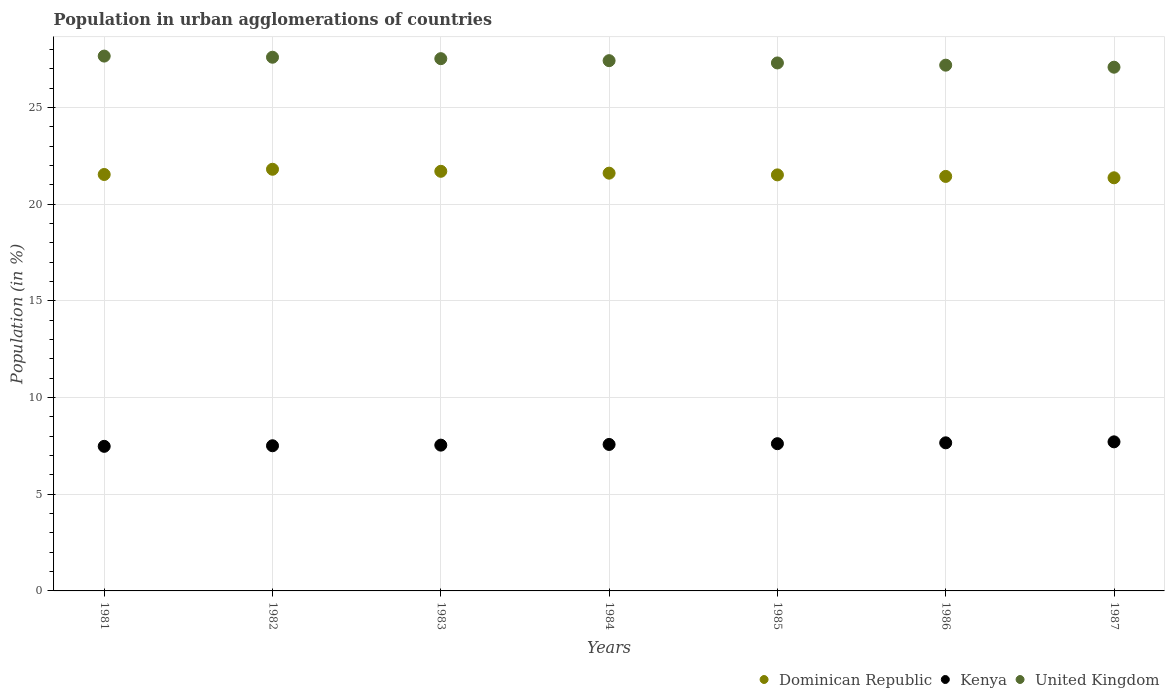Is the number of dotlines equal to the number of legend labels?
Your response must be concise. Yes. What is the percentage of population in urban agglomerations in Kenya in 1982?
Give a very brief answer. 7.51. Across all years, what is the maximum percentage of population in urban agglomerations in Kenya?
Your answer should be very brief. 7.71. Across all years, what is the minimum percentage of population in urban agglomerations in Kenya?
Make the answer very short. 7.48. In which year was the percentage of population in urban agglomerations in Kenya maximum?
Your answer should be very brief. 1987. What is the total percentage of population in urban agglomerations in Kenya in the graph?
Your answer should be very brief. 53.09. What is the difference between the percentage of population in urban agglomerations in Kenya in 1986 and that in 1987?
Offer a very short reply. -0.05. What is the difference between the percentage of population in urban agglomerations in Kenya in 1983 and the percentage of population in urban agglomerations in United Kingdom in 1982?
Offer a terse response. -20.06. What is the average percentage of population in urban agglomerations in Kenya per year?
Make the answer very short. 7.58. In the year 1982, what is the difference between the percentage of population in urban agglomerations in United Kingdom and percentage of population in urban agglomerations in Dominican Republic?
Give a very brief answer. 5.79. What is the ratio of the percentage of population in urban agglomerations in United Kingdom in 1984 to that in 1987?
Keep it short and to the point. 1.01. Is the percentage of population in urban agglomerations in United Kingdom in 1984 less than that in 1986?
Ensure brevity in your answer.  No. What is the difference between the highest and the second highest percentage of population in urban agglomerations in Dominican Republic?
Ensure brevity in your answer.  0.11. What is the difference between the highest and the lowest percentage of population in urban agglomerations in Dominican Republic?
Provide a short and direct response. 0.44. Does the percentage of population in urban agglomerations in Dominican Republic monotonically increase over the years?
Offer a very short reply. No. Is the percentage of population in urban agglomerations in United Kingdom strictly greater than the percentage of population in urban agglomerations in Dominican Republic over the years?
Keep it short and to the point. Yes. Is the percentage of population in urban agglomerations in Dominican Republic strictly less than the percentage of population in urban agglomerations in Kenya over the years?
Ensure brevity in your answer.  No. How many years are there in the graph?
Ensure brevity in your answer.  7. Does the graph contain any zero values?
Keep it short and to the point. No. Where does the legend appear in the graph?
Give a very brief answer. Bottom right. What is the title of the graph?
Give a very brief answer. Population in urban agglomerations of countries. Does "Curacao" appear as one of the legend labels in the graph?
Offer a very short reply. No. What is the label or title of the Y-axis?
Give a very brief answer. Population (in %). What is the Population (in %) in Dominican Republic in 1981?
Provide a succinct answer. 21.54. What is the Population (in %) of Kenya in 1981?
Your response must be concise. 7.48. What is the Population (in %) of United Kingdom in 1981?
Keep it short and to the point. 27.66. What is the Population (in %) of Dominican Republic in 1982?
Provide a succinct answer. 21.81. What is the Population (in %) in Kenya in 1982?
Your response must be concise. 7.51. What is the Population (in %) of United Kingdom in 1982?
Ensure brevity in your answer.  27.6. What is the Population (in %) in Dominican Republic in 1983?
Your response must be concise. 21.7. What is the Population (in %) of Kenya in 1983?
Offer a terse response. 7.54. What is the Population (in %) of United Kingdom in 1983?
Make the answer very short. 27.53. What is the Population (in %) of Dominican Republic in 1984?
Make the answer very short. 21.61. What is the Population (in %) in Kenya in 1984?
Your answer should be compact. 7.58. What is the Population (in %) in United Kingdom in 1984?
Your response must be concise. 27.43. What is the Population (in %) of Dominican Republic in 1985?
Your answer should be very brief. 21.52. What is the Population (in %) in Kenya in 1985?
Provide a short and direct response. 7.62. What is the Population (in %) of United Kingdom in 1985?
Give a very brief answer. 27.31. What is the Population (in %) of Dominican Republic in 1986?
Provide a short and direct response. 21.44. What is the Population (in %) of Kenya in 1986?
Your response must be concise. 7.66. What is the Population (in %) in United Kingdom in 1986?
Your answer should be compact. 27.19. What is the Population (in %) of Dominican Republic in 1987?
Offer a terse response. 21.37. What is the Population (in %) of Kenya in 1987?
Make the answer very short. 7.71. What is the Population (in %) of United Kingdom in 1987?
Make the answer very short. 27.09. Across all years, what is the maximum Population (in %) of Dominican Republic?
Offer a terse response. 21.81. Across all years, what is the maximum Population (in %) of Kenya?
Your answer should be compact. 7.71. Across all years, what is the maximum Population (in %) of United Kingdom?
Your answer should be very brief. 27.66. Across all years, what is the minimum Population (in %) in Dominican Republic?
Offer a terse response. 21.37. Across all years, what is the minimum Population (in %) in Kenya?
Offer a terse response. 7.48. Across all years, what is the minimum Population (in %) in United Kingdom?
Give a very brief answer. 27.09. What is the total Population (in %) of Dominican Republic in the graph?
Your answer should be compact. 150.99. What is the total Population (in %) of Kenya in the graph?
Give a very brief answer. 53.09. What is the total Population (in %) in United Kingdom in the graph?
Your answer should be very brief. 191.81. What is the difference between the Population (in %) in Dominican Republic in 1981 and that in 1982?
Offer a terse response. -0.27. What is the difference between the Population (in %) in Kenya in 1981 and that in 1982?
Keep it short and to the point. -0.03. What is the difference between the Population (in %) in United Kingdom in 1981 and that in 1982?
Make the answer very short. 0.06. What is the difference between the Population (in %) in Dominican Republic in 1981 and that in 1983?
Make the answer very short. -0.16. What is the difference between the Population (in %) of Kenya in 1981 and that in 1983?
Your response must be concise. -0.06. What is the difference between the Population (in %) of United Kingdom in 1981 and that in 1983?
Provide a succinct answer. 0.13. What is the difference between the Population (in %) of Dominican Republic in 1981 and that in 1984?
Your answer should be compact. -0.07. What is the difference between the Population (in %) in Kenya in 1981 and that in 1984?
Make the answer very short. -0.1. What is the difference between the Population (in %) in United Kingdom in 1981 and that in 1984?
Ensure brevity in your answer.  0.24. What is the difference between the Population (in %) of Dominican Republic in 1981 and that in 1985?
Give a very brief answer. 0.02. What is the difference between the Population (in %) in Kenya in 1981 and that in 1985?
Ensure brevity in your answer.  -0.14. What is the difference between the Population (in %) of United Kingdom in 1981 and that in 1985?
Your answer should be compact. 0.35. What is the difference between the Population (in %) of Dominican Republic in 1981 and that in 1986?
Your response must be concise. 0.1. What is the difference between the Population (in %) of Kenya in 1981 and that in 1986?
Offer a terse response. -0.18. What is the difference between the Population (in %) in United Kingdom in 1981 and that in 1986?
Offer a very short reply. 0.47. What is the difference between the Population (in %) of Dominican Republic in 1981 and that in 1987?
Provide a succinct answer. 0.17. What is the difference between the Population (in %) of Kenya in 1981 and that in 1987?
Make the answer very short. -0.23. What is the difference between the Population (in %) of United Kingdom in 1981 and that in 1987?
Keep it short and to the point. 0.57. What is the difference between the Population (in %) in Dominican Republic in 1982 and that in 1983?
Your answer should be very brief. 0.11. What is the difference between the Population (in %) in Kenya in 1982 and that in 1983?
Keep it short and to the point. -0.03. What is the difference between the Population (in %) in United Kingdom in 1982 and that in 1983?
Make the answer very short. 0.07. What is the difference between the Population (in %) in Dominican Republic in 1982 and that in 1984?
Your answer should be compact. 0.2. What is the difference between the Population (in %) in Kenya in 1982 and that in 1984?
Your answer should be very brief. -0.07. What is the difference between the Population (in %) of United Kingdom in 1982 and that in 1984?
Your response must be concise. 0.18. What is the difference between the Population (in %) in Dominican Republic in 1982 and that in 1985?
Your answer should be compact. 0.29. What is the difference between the Population (in %) of Kenya in 1982 and that in 1985?
Ensure brevity in your answer.  -0.11. What is the difference between the Population (in %) of United Kingdom in 1982 and that in 1985?
Offer a terse response. 0.3. What is the difference between the Population (in %) of Dominican Republic in 1982 and that in 1986?
Provide a short and direct response. 0.37. What is the difference between the Population (in %) of Kenya in 1982 and that in 1986?
Your answer should be compact. -0.15. What is the difference between the Population (in %) of United Kingdom in 1982 and that in 1986?
Your answer should be very brief. 0.41. What is the difference between the Population (in %) in Dominican Republic in 1982 and that in 1987?
Give a very brief answer. 0.44. What is the difference between the Population (in %) of Kenya in 1982 and that in 1987?
Provide a succinct answer. -0.2. What is the difference between the Population (in %) of United Kingdom in 1982 and that in 1987?
Your response must be concise. 0.52. What is the difference between the Population (in %) of Dominican Republic in 1983 and that in 1984?
Ensure brevity in your answer.  0.1. What is the difference between the Population (in %) in Kenya in 1983 and that in 1984?
Your answer should be very brief. -0.04. What is the difference between the Population (in %) in United Kingdom in 1983 and that in 1984?
Provide a succinct answer. 0.1. What is the difference between the Population (in %) in Dominican Republic in 1983 and that in 1985?
Ensure brevity in your answer.  0.18. What is the difference between the Population (in %) of Kenya in 1983 and that in 1985?
Provide a succinct answer. -0.07. What is the difference between the Population (in %) of United Kingdom in 1983 and that in 1985?
Your answer should be very brief. 0.22. What is the difference between the Population (in %) in Dominican Republic in 1983 and that in 1986?
Your answer should be compact. 0.26. What is the difference between the Population (in %) of Kenya in 1983 and that in 1986?
Give a very brief answer. -0.12. What is the difference between the Population (in %) in United Kingdom in 1983 and that in 1986?
Your answer should be compact. 0.34. What is the difference between the Population (in %) in Dominican Republic in 1983 and that in 1987?
Make the answer very short. 0.34. What is the difference between the Population (in %) of Kenya in 1983 and that in 1987?
Give a very brief answer. -0.17. What is the difference between the Population (in %) in United Kingdom in 1983 and that in 1987?
Provide a succinct answer. 0.44. What is the difference between the Population (in %) in Dominican Republic in 1984 and that in 1985?
Ensure brevity in your answer.  0.09. What is the difference between the Population (in %) of Kenya in 1984 and that in 1985?
Make the answer very short. -0.04. What is the difference between the Population (in %) of United Kingdom in 1984 and that in 1985?
Offer a very short reply. 0.12. What is the difference between the Population (in %) in Dominican Republic in 1984 and that in 1986?
Provide a short and direct response. 0.17. What is the difference between the Population (in %) of Kenya in 1984 and that in 1986?
Your response must be concise. -0.08. What is the difference between the Population (in %) of United Kingdom in 1984 and that in 1986?
Offer a very short reply. 0.23. What is the difference between the Population (in %) in Dominican Republic in 1984 and that in 1987?
Your answer should be very brief. 0.24. What is the difference between the Population (in %) in Kenya in 1984 and that in 1987?
Your answer should be compact. -0.13. What is the difference between the Population (in %) in United Kingdom in 1984 and that in 1987?
Offer a terse response. 0.34. What is the difference between the Population (in %) of Dominican Republic in 1985 and that in 1986?
Provide a succinct answer. 0.08. What is the difference between the Population (in %) of Kenya in 1985 and that in 1986?
Your answer should be compact. -0.04. What is the difference between the Population (in %) in United Kingdom in 1985 and that in 1986?
Your response must be concise. 0.11. What is the difference between the Population (in %) in Dominican Republic in 1985 and that in 1987?
Your answer should be very brief. 0.15. What is the difference between the Population (in %) in Kenya in 1985 and that in 1987?
Keep it short and to the point. -0.1. What is the difference between the Population (in %) of United Kingdom in 1985 and that in 1987?
Give a very brief answer. 0.22. What is the difference between the Population (in %) in Dominican Republic in 1986 and that in 1987?
Your response must be concise. 0.07. What is the difference between the Population (in %) of Kenya in 1986 and that in 1987?
Your response must be concise. -0.05. What is the difference between the Population (in %) in United Kingdom in 1986 and that in 1987?
Give a very brief answer. 0.11. What is the difference between the Population (in %) in Dominican Republic in 1981 and the Population (in %) in Kenya in 1982?
Make the answer very short. 14.03. What is the difference between the Population (in %) in Dominican Republic in 1981 and the Population (in %) in United Kingdom in 1982?
Make the answer very short. -6.06. What is the difference between the Population (in %) in Kenya in 1981 and the Population (in %) in United Kingdom in 1982?
Your response must be concise. -20.13. What is the difference between the Population (in %) of Dominican Republic in 1981 and the Population (in %) of Kenya in 1983?
Provide a succinct answer. 14. What is the difference between the Population (in %) in Dominican Republic in 1981 and the Population (in %) in United Kingdom in 1983?
Your response must be concise. -5.99. What is the difference between the Population (in %) in Kenya in 1981 and the Population (in %) in United Kingdom in 1983?
Your response must be concise. -20.05. What is the difference between the Population (in %) in Dominican Republic in 1981 and the Population (in %) in Kenya in 1984?
Offer a terse response. 13.96. What is the difference between the Population (in %) of Dominican Republic in 1981 and the Population (in %) of United Kingdom in 1984?
Your answer should be very brief. -5.89. What is the difference between the Population (in %) in Kenya in 1981 and the Population (in %) in United Kingdom in 1984?
Your response must be concise. -19.95. What is the difference between the Population (in %) of Dominican Republic in 1981 and the Population (in %) of Kenya in 1985?
Provide a short and direct response. 13.92. What is the difference between the Population (in %) of Dominican Republic in 1981 and the Population (in %) of United Kingdom in 1985?
Offer a very short reply. -5.77. What is the difference between the Population (in %) in Kenya in 1981 and the Population (in %) in United Kingdom in 1985?
Provide a succinct answer. -19.83. What is the difference between the Population (in %) in Dominican Republic in 1981 and the Population (in %) in Kenya in 1986?
Keep it short and to the point. 13.88. What is the difference between the Population (in %) of Dominican Republic in 1981 and the Population (in %) of United Kingdom in 1986?
Ensure brevity in your answer.  -5.65. What is the difference between the Population (in %) in Kenya in 1981 and the Population (in %) in United Kingdom in 1986?
Give a very brief answer. -19.72. What is the difference between the Population (in %) of Dominican Republic in 1981 and the Population (in %) of Kenya in 1987?
Keep it short and to the point. 13.83. What is the difference between the Population (in %) in Dominican Republic in 1981 and the Population (in %) in United Kingdom in 1987?
Your answer should be compact. -5.55. What is the difference between the Population (in %) of Kenya in 1981 and the Population (in %) of United Kingdom in 1987?
Offer a terse response. -19.61. What is the difference between the Population (in %) of Dominican Republic in 1982 and the Population (in %) of Kenya in 1983?
Keep it short and to the point. 14.27. What is the difference between the Population (in %) of Dominican Republic in 1982 and the Population (in %) of United Kingdom in 1983?
Make the answer very short. -5.72. What is the difference between the Population (in %) of Kenya in 1982 and the Population (in %) of United Kingdom in 1983?
Offer a terse response. -20.02. What is the difference between the Population (in %) in Dominican Republic in 1982 and the Population (in %) in Kenya in 1984?
Ensure brevity in your answer.  14.23. What is the difference between the Population (in %) of Dominican Republic in 1982 and the Population (in %) of United Kingdom in 1984?
Offer a terse response. -5.62. What is the difference between the Population (in %) in Kenya in 1982 and the Population (in %) in United Kingdom in 1984?
Your response must be concise. -19.92. What is the difference between the Population (in %) of Dominican Republic in 1982 and the Population (in %) of Kenya in 1985?
Make the answer very short. 14.19. What is the difference between the Population (in %) in Dominican Republic in 1982 and the Population (in %) in United Kingdom in 1985?
Your answer should be very brief. -5.5. What is the difference between the Population (in %) in Kenya in 1982 and the Population (in %) in United Kingdom in 1985?
Keep it short and to the point. -19.8. What is the difference between the Population (in %) of Dominican Republic in 1982 and the Population (in %) of Kenya in 1986?
Make the answer very short. 14.15. What is the difference between the Population (in %) of Dominican Republic in 1982 and the Population (in %) of United Kingdom in 1986?
Keep it short and to the point. -5.38. What is the difference between the Population (in %) in Kenya in 1982 and the Population (in %) in United Kingdom in 1986?
Ensure brevity in your answer.  -19.69. What is the difference between the Population (in %) in Dominican Republic in 1982 and the Population (in %) in Kenya in 1987?
Your answer should be very brief. 14.1. What is the difference between the Population (in %) of Dominican Republic in 1982 and the Population (in %) of United Kingdom in 1987?
Provide a succinct answer. -5.28. What is the difference between the Population (in %) of Kenya in 1982 and the Population (in %) of United Kingdom in 1987?
Your response must be concise. -19.58. What is the difference between the Population (in %) in Dominican Republic in 1983 and the Population (in %) in Kenya in 1984?
Give a very brief answer. 14.13. What is the difference between the Population (in %) in Dominican Republic in 1983 and the Population (in %) in United Kingdom in 1984?
Provide a succinct answer. -5.72. What is the difference between the Population (in %) of Kenya in 1983 and the Population (in %) of United Kingdom in 1984?
Keep it short and to the point. -19.89. What is the difference between the Population (in %) in Dominican Republic in 1983 and the Population (in %) in Kenya in 1985?
Offer a very short reply. 14.09. What is the difference between the Population (in %) in Dominican Republic in 1983 and the Population (in %) in United Kingdom in 1985?
Offer a terse response. -5.6. What is the difference between the Population (in %) of Kenya in 1983 and the Population (in %) of United Kingdom in 1985?
Offer a very short reply. -19.77. What is the difference between the Population (in %) in Dominican Republic in 1983 and the Population (in %) in Kenya in 1986?
Your answer should be very brief. 14.04. What is the difference between the Population (in %) in Dominican Republic in 1983 and the Population (in %) in United Kingdom in 1986?
Your answer should be compact. -5.49. What is the difference between the Population (in %) of Kenya in 1983 and the Population (in %) of United Kingdom in 1986?
Provide a succinct answer. -19.65. What is the difference between the Population (in %) of Dominican Republic in 1983 and the Population (in %) of Kenya in 1987?
Offer a very short reply. 13.99. What is the difference between the Population (in %) in Dominican Republic in 1983 and the Population (in %) in United Kingdom in 1987?
Ensure brevity in your answer.  -5.38. What is the difference between the Population (in %) in Kenya in 1983 and the Population (in %) in United Kingdom in 1987?
Provide a succinct answer. -19.55. What is the difference between the Population (in %) in Dominican Republic in 1984 and the Population (in %) in Kenya in 1985?
Offer a very short reply. 13.99. What is the difference between the Population (in %) in Dominican Republic in 1984 and the Population (in %) in United Kingdom in 1985?
Provide a short and direct response. -5.7. What is the difference between the Population (in %) in Kenya in 1984 and the Population (in %) in United Kingdom in 1985?
Your answer should be very brief. -19.73. What is the difference between the Population (in %) of Dominican Republic in 1984 and the Population (in %) of Kenya in 1986?
Ensure brevity in your answer.  13.95. What is the difference between the Population (in %) in Dominican Republic in 1984 and the Population (in %) in United Kingdom in 1986?
Give a very brief answer. -5.59. What is the difference between the Population (in %) of Kenya in 1984 and the Population (in %) of United Kingdom in 1986?
Provide a short and direct response. -19.62. What is the difference between the Population (in %) of Dominican Republic in 1984 and the Population (in %) of Kenya in 1987?
Your answer should be compact. 13.9. What is the difference between the Population (in %) in Dominican Republic in 1984 and the Population (in %) in United Kingdom in 1987?
Provide a short and direct response. -5.48. What is the difference between the Population (in %) in Kenya in 1984 and the Population (in %) in United Kingdom in 1987?
Offer a very short reply. -19.51. What is the difference between the Population (in %) in Dominican Republic in 1985 and the Population (in %) in Kenya in 1986?
Give a very brief answer. 13.86. What is the difference between the Population (in %) of Dominican Republic in 1985 and the Population (in %) of United Kingdom in 1986?
Provide a succinct answer. -5.67. What is the difference between the Population (in %) of Kenya in 1985 and the Population (in %) of United Kingdom in 1986?
Keep it short and to the point. -19.58. What is the difference between the Population (in %) in Dominican Republic in 1985 and the Population (in %) in Kenya in 1987?
Provide a short and direct response. 13.81. What is the difference between the Population (in %) of Dominican Republic in 1985 and the Population (in %) of United Kingdom in 1987?
Provide a succinct answer. -5.57. What is the difference between the Population (in %) of Kenya in 1985 and the Population (in %) of United Kingdom in 1987?
Provide a short and direct response. -19.47. What is the difference between the Population (in %) of Dominican Republic in 1986 and the Population (in %) of Kenya in 1987?
Your answer should be compact. 13.73. What is the difference between the Population (in %) in Dominican Republic in 1986 and the Population (in %) in United Kingdom in 1987?
Make the answer very short. -5.65. What is the difference between the Population (in %) in Kenya in 1986 and the Population (in %) in United Kingdom in 1987?
Give a very brief answer. -19.43. What is the average Population (in %) of Dominican Republic per year?
Your answer should be compact. 21.57. What is the average Population (in %) of Kenya per year?
Keep it short and to the point. 7.58. What is the average Population (in %) of United Kingdom per year?
Your answer should be very brief. 27.4. In the year 1981, what is the difference between the Population (in %) in Dominican Republic and Population (in %) in Kenya?
Your answer should be compact. 14.06. In the year 1981, what is the difference between the Population (in %) in Dominican Republic and Population (in %) in United Kingdom?
Your answer should be compact. -6.12. In the year 1981, what is the difference between the Population (in %) of Kenya and Population (in %) of United Kingdom?
Keep it short and to the point. -20.18. In the year 1982, what is the difference between the Population (in %) of Dominican Republic and Population (in %) of Kenya?
Keep it short and to the point. 14.3. In the year 1982, what is the difference between the Population (in %) of Dominican Republic and Population (in %) of United Kingdom?
Keep it short and to the point. -5.79. In the year 1982, what is the difference between the Population (in %) of Kenya and Population (in %) of United Kingdom?
Provide a short and direct response. -20.1. In the year 1983, what is the difference between the Population (in %) of Dominican Republic and Population (in %) of Kenya?
Provide a short and direct response. 14.16. In the year 1983, what is the difference between the Population (in %) in Dominican Republic and Population (in %) in United Kingdom?
Provide a short and direct response. -5.83. In the year 1983, what is the difference between the Population (in %) of Kenya and Population (in %) of United Kingdom?
Provide a succinct answer. -19.99. In the year 1984, what is the difference between the Population (in %) in Dominican Republic and Population (in %) in Kenya?
Your response must be concise. 14.03. In the year 1984, what is the difference between the Population (in %) in Dominican Republic and Population (in %) in United Kingdom?
Provide a succinct answer. -5.82. In the year 1984, what is the difference between the Population (in %) in Kenya and Population (in %) in United Kingdom?
Your answer should be compact. -19.85. In the year 1985, what is the difference between the Population (in %) of Dominican Republic and Population (in %) of Kenya?
Offer a terse response. 13.9. In the year 1985, what is the difference between the Population (in %) in Dominican Republic and Population (in %) in United Kingdom?
Give a very brief answer. -5.79. In the year 1985, what is the difference between the Population (in %) in Kenya and Population (in %) in United Kingdom?
Offer a very short reply. -19.69. In the year 1986, what is the difference between the Population (in %) of Dominican Republic and Population (in %) of Kenya?
Keep it short and to the point. 13.78. In the year 1986, what is the difference between the Population (in %) in Dominican Republic and Population (in %) in United Kingdom?
Give a very brief answer. -5.75. In the year 1986, what is the difference between the Population (in %) of Kenya and Population (in %) of United Kingdom?
Ensure brevity in your answer.  -19.53. In the year 1987, what is the difference between the Population (in %) of Dominican Republic and Population (in %) of Kenya?
Your response must be concise. 13.66. In the year 1987, what is the difference between the Population (in %) of Dominican Republic and Population (in %) of United Kingdom?
Give a very brief answer. -5.72. In the year 1987, what is the difference between the Population (in %) in Kenya and Population (in %) in United Kingdom?
Offer a very short reply. -19.38. What is the ratio of the Population (in %) in Dominican Republic in 1981 to that in 1982?
Ensure brevity in your answer.  0.99. What is the ratio of the Population (in %) of United Kingdom in 1981 to that in 1982?
Provide a short and direct response. 1. What is the ratio of the Population (in %) of Dominican Republic in 1981 to that in 1983?
Ensure brevity in your answer.  0.99. What is the ratio of the Population (in %) of United Kingdom in 1981 to that in 1983?
Provide a succinct answer. 1. What is the ratio of the Population (in %) in Dominican Republic in 1981 to that in 1984?
Provide a short and direct response. 1. What is the ratio of the Population (in %) in Kenya in 1981 to that in 1984?
Provide a short and direct response. 0.99. What is the ratio of the Population (in %) in United Kingdom in 1981 to that in 1984?
Ensure brevity in your answer.  1.01. What is the ratio of the Population (in %) in Dominican Republic in 1981 to that in 1985?
Keep it short and to the point. 1. What is the ratio of the Population (in %) of United Kingdom in 1981 to that in 1985?
Your answer should be very brief. 1.01. What is the ratio of the Population (in %) in Kenya in 1981 to that in 1986?
Your answer should be compact. 0.98. What is the ratio of the Population (in %) in United Kingdom in 1981 to that in 1986?
Give a very brief answer. 1.02. What is the ratio of the Population (in %) in Kenya in 1981 to that in 1987?
Ensure brevity in your answer.  0.97. What is the ratio of the Population (in %) in United Kingdom in 1981 to that in 1987?
Your answer should be compact. 1.02. What is the ratio of the Population (in %) of Kenya in 1982 to that in 1983?
Give a very brief answer. 1. What is the ratio of the Population (in %) of United Kingdom in 1982 to that in 1983?
Give a very brief answer. 1. What is the ratio of the Population (in %) in Dominican Republic in 1982 to that in 1984?
Provide a short and direct response. 1.01. What is the ratio of the Population (in %) of Dominican Republic in 1982 to that in 1985?
Your answer should be very brief. 1.01. What is the ratio of the Population (in %) in Kenya in 1982 to that in 1985?
Offer a very short reply. 0.99. What is the ratio of the Population (in %) of United Kingdom in 1982 to that in 1985?
Ensure brevity in your answer.  1.01. What is the ratio of the Population (in %) in Dominican Republic in 1982 to that in 1986?
Make the answer very short. 1.02. What is the ratio of the Population (in %) in Kenya in 1982 to that in 1986?
Offer a terse response. 0.98. What is the ratio of the Population (in %) in United Kingdom in 1982 to that in 1986?
Your answer should be compact. 1.02. What is the ratio of the Population (in %) of Dominican Republic in 1982 to that in 1987?
Make the answer very short. 1.02. What is the ratio of the Population (in %) in Kenya in 1982 to that in 1987?
Provide a short and direct response. 0.97. What is the ratio of the Population (in %) of Dominican Republic in 1983 to that in 1984?
Provide a short and direct response. 1. What is the ratio of the Population (in %) of Dominican Republic in 1983 to that in 1985?
Your answer should be very brief. 1.01. What is the ratio of the Population (in %) in Kenya in 1983 to that in 1985?
Ensure brevity in your answer.  0.99. What is the ratio of the Population (in %) of Dominican Republic in 1983 to that in 1986?
Keep it short and to the point. 1.01. What is the ratio of the Population (in %) of Kenya in 1983 to that in 1986?
Make the answer very short. 0.98. What is the ratio of the Population (in %) of United Kingdom in 1983 to that in 1986?
Provide a short and direct response. 1.01. What is the ratio of the Population (in %) in Dominican Republic in 1983 to that in 1987?
Your answer should be very brief. 1.02. What is the ratio of the Population (in %) of Kenya in 1983 to that in 1987?
Your answer should be very brief. 0.98. What is the ratio of the Population (in %) in United Kingdom in 1983 to that in 1987?
Provide a short and direct response. 1.02. What is the ratio of the Population (in %) of Dominican Republic in 1984 to that in 1986?
Make the answer very short. 1.01. What is the ratio of the Population (in %) in United Kingdom in 1984 to that in 1986?
Your answer should be compact. 1.01. What is the ratio of the Population (in %) in Dominican Republic in 1984 to that in 1987?
Ensure brevity in your answer.  1.01. What is the ratio of the Population (in %) of Kenya in 1984 to that in 1987?
Give a very brief answer. 0.98. What is the ratio of the Population (in %) of United Kingdom in 1984 to that in 1987?
Your response must be concise. 1.01. What is the ratio of the Population (in %) of Dominican Republic in 1985 to that in 1986?
Provide a short and direct response. 1. What is the ratio of the Population (in %) of Kenya in 1985 to that in 1986?
Your response must be concise. 0.99. What is the ratio of the Population (in %) in Dominican Republic in 1985 to that in 1987?
Give a very brief answer. 1.01. What is the ratio of the Population (in %) in Kenya in 1985 to that in 1987?
Keep it short and to the point. 0.99. What is the ratio of the Population (in %) of United Kingdom in 1985 to that in 1987?
Keep it short and to the point. 1.01. What is the ratio of the Population (in %) of Dominican Republic in 1986 to that in 1987?
Provide a succinct answer. 1. What is the ratio of the Population (in %) in Kenya in 1986 to that in 1987?
Give a very brief answer. 0.99. What is the difference between the highest and the second highest Population (in %) in Dominican Republic?
Ensure brevity in your answer.  0.11. What is the difference between the highest and the second highest Population (in %) in Kenya?
Give a very brief answer. 0.05. What is the difference between the highest and the second highest Population (in %) in United Kingdom?
Give a very brief answer. 0.06. What is the difference between the highest and the lowest Population (in %) of Dominican Republic?
Offer a very short reply. 0.44. What is the difference between the highest and the lowest Population (in %) in Kenya?
Your answer should be compact. 0.23. What is the difference between the highest and the lowest Population (in %) in United Kingdom?
Give a very brief answer. 0.57. 